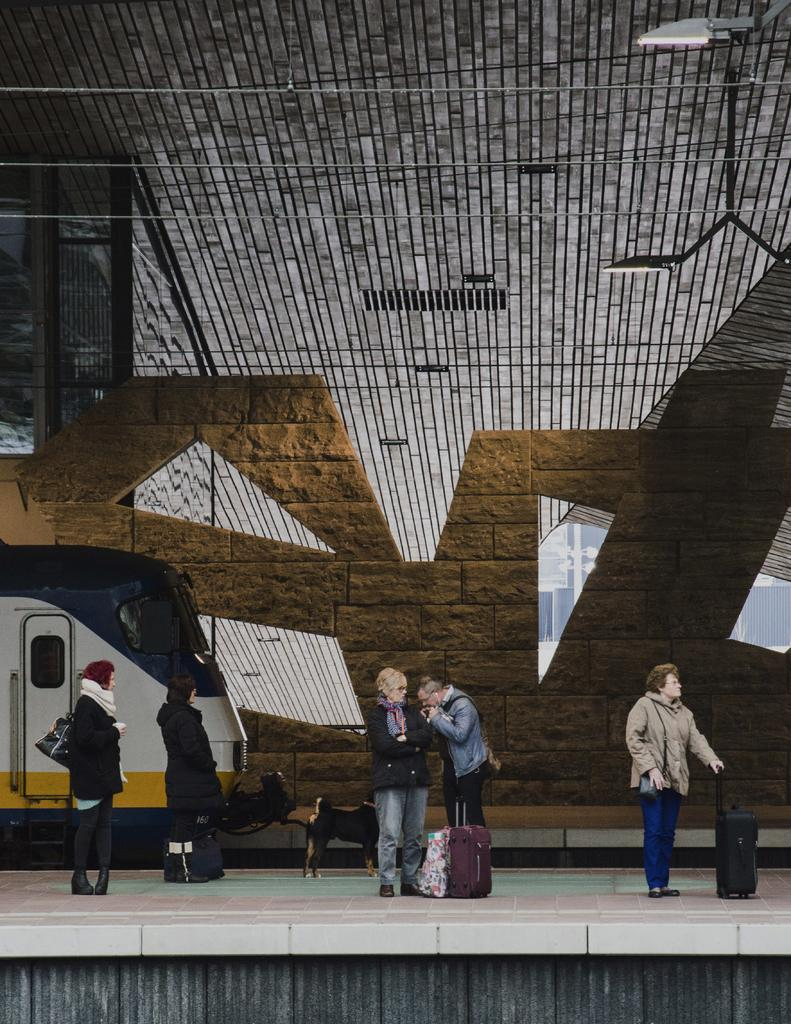What are the people in the image doing? The people in the image are standing on a platform. What can be seen near the people on the platform? There are bags visible near the people. What is located on the left side of the image? There is a train on the left side of the image. What type of thunder can be heard in the image? There is no thunder present in the image, as it is a visual representation and does not include sound. 